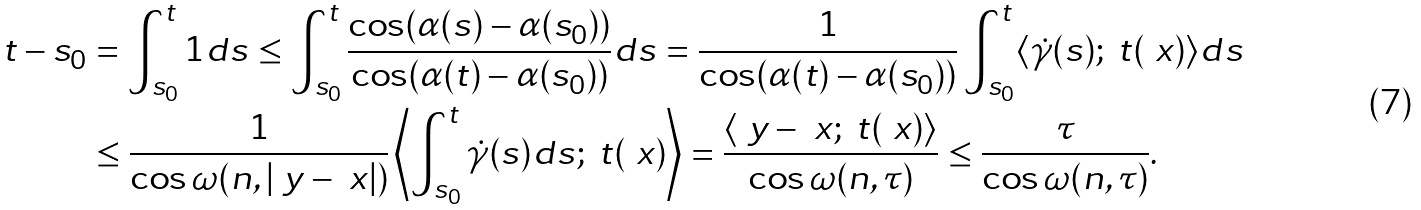<formula> <loc_0><loc_0><loc_500><loc_500>t - s _ { 0 } & = \int _ { s _ { 0 } } ^ { t } 1 d s \leq \int _ { s _ { 0 } } ^ { t } \frac { \cos ( \alpha ( s ) - \alpha ( s _ { 0 } ) ) } { \cos ( \alpha ( t ) - \alpha ( s _ { 0 } ) ) } d s = \frac { 1 } { \cos ( \alpha ( t ) - \alpha ( s _ { 0 } ) ) } \int _ { s _ { 0 } } ^ { t } \langle \dot { \gamma } ( s ) ; \ t ( \ x ) \rangle d s \\ & \leq \frac { 1 } { \cos \omega ( n , | \ y - \ x | ) } \left \langle \int _ { s _ { 0 } } ^ { t } \dot { \gamma } ( s ) d s ; \ t ( \ x ) \right \rangle = \frac { \left \langle \ y - \ x ; \ t ( \ x ) \right \rangle } { \cos \omega ( n , \tau ) } \leq \frac { \tau } { \cos \omega ( n , \tau ) } .</formula> 